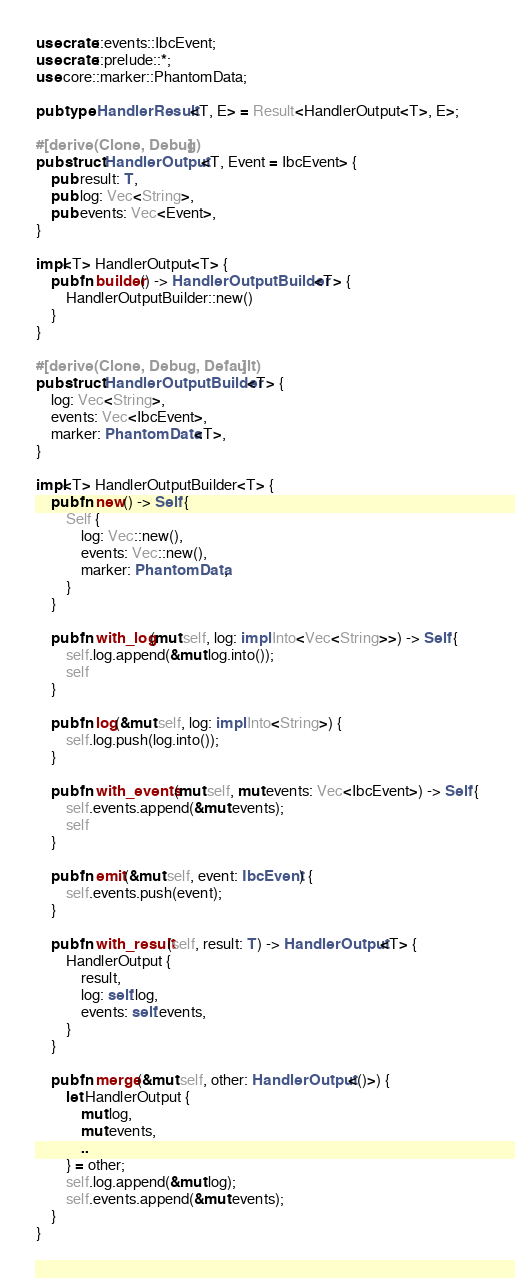<code> <loc_0><loc_0><loc_500><loc_500><_Rust_>use crate::events::IbcEvent;
use crate::prelude::*;
use core::marker::PhantomData;

pub type HandlerResult<T, E> = Result<HandlerOutput<T>, E>;

#[derive(Clone, Debug)]
pub struct HandlerOutput<T, Event = IbcEvent> {
    pub result: T,
    pub log: Vec<String>,
    pub events: Vec<Event>,
}

impl<T> HandlerOutput<T> {
    pub fn builder() -> HandlerOutputBuilder<T> {
        HandlerOutputBuilder::new()
    }
}

#[derive(Clone, Debug, Default)]
pub struct HandlerOutputBuilder<T> {
    log: Vec<String>,
    events: Vec<IbcEvent>,
    marker: PhantomData<T>,
}

impl<T> HandlerOutputBuilder<T> {
    pub fn new() -> Self {
        Self {
            log: Vec::new(),
            events: Vec::new(),
            marker: PhantomData,
        }
    }

    pub fn with_log(mut self, log: impl Into<Vec<String>>) -> Self {
        self.log.append(&mut log.into());
        self
    }

    pub fn log(&mut self, log: impl Into<String>) {
        self.log.push(log.into());
    }

    pub fn with_events(mut self, mut events: Vec<IbcEvent>) -> Self {
        self.events.append(&mut events);
        self
    }

    pub fn emit(&mut self, event: IbcEvent) {
        self.events.push(event);
    }

    pub fn with_result(self, result: T) -> HandlerOutput<T> {
        HandlerOutput {
            result,
            log: self.log,
            events: self.events,
        }
    }

    pub fn merge(&mut self, other: HandlerOutput<()>) {
        let HandlerOutput {
            mut log,
            mut events,
            ..
        } = other;
        self.log.append(&mut log);
        self.events.append(&mut events);
    }
}
</code> 